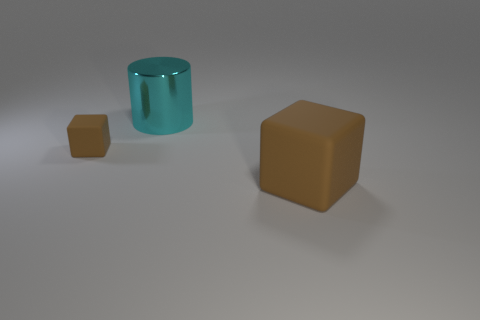How many things are tiny yellow matte things or brown blocks that are on the left side of the big block?
Offer a very short reply. 1. Is there a tiny brown object made of the same material as the large cyan cylinder?
Make the answer very short. No. There is a brown object that is the same size as the cyan object; what is it made of?
Provide a succinct answer. Rubber. What material is the large object behind the tiny brown cube that is on the left side of the big rubber cube?
Ensure brevity in your answer.  Metal. Does the rubber thing on the left side of the large rubber thing have the same shape as the shiny object?
Provide a succinct answer. No. There is a tiny thing that is made of the same material as the big cube; what is its color?
Your response must be concise. Brown. What material is the brown thing in front of the tiny matte block?
Offer a very short reply. Rubber. There is a small thing; does it have the same shape as the large object that is behind the large brown matte cube?
Your answer should be very brief. No. The thing that is both behind the large matte object and in front of the large cyan object is made of what material?
Ensure brevity in your answer.  Rubber. What is the color of the rubber block that is the same size as the cyan metallic object?
Ensure brevity in your answer.  Brown. 